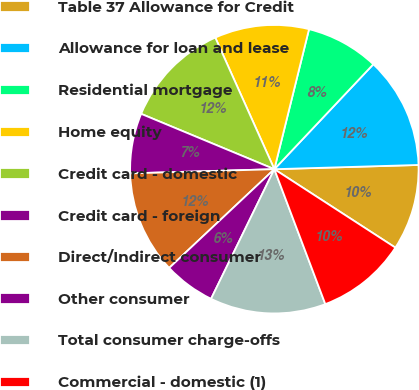Convert chart to OTSL. <chart><loc_0><loc_0><loc_500><loc_500><pie_chart><fcel>Table 37 Allowance for Credit<fcel>Allowance for loan and lease<fcel>Residential mortgage<fcel>Home equity<fcel>Credit card - domestic<fcel>Credit card - foreign<fcel>Direct/Indirect consumer<fcel>Other consumer<fcel>Total consumer charge-offs<fcel>Commercial - domestic (1)<nl><fcel>9.62%<fcel>12.5%<fcel>8.17%<fcel>10.58%<fcel>12.02%<fcel>6.73%<fcel>11.54%<fcel>5.77%<fcel>12.98%<fcel>10.1%<nl></chart> 